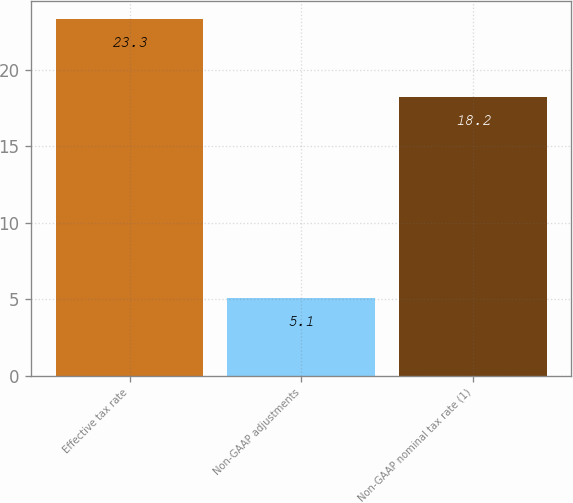<chart> <loc_0><loc_0><loc_500><loc_500><bar_chart><fcel>Effective tax rate<fcel>Non-GAAP adjustments<fcel>Non-GAAP nominal tax rate (1)<nl><fcel>23.3<fcel>5.1<fcel>18.2<nl></chart> 